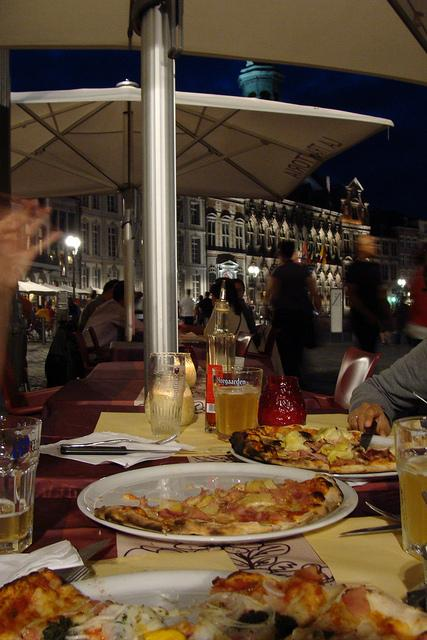What is this place? Please explain your reasoning. outdoor restaurant. The place is serving food outside. 